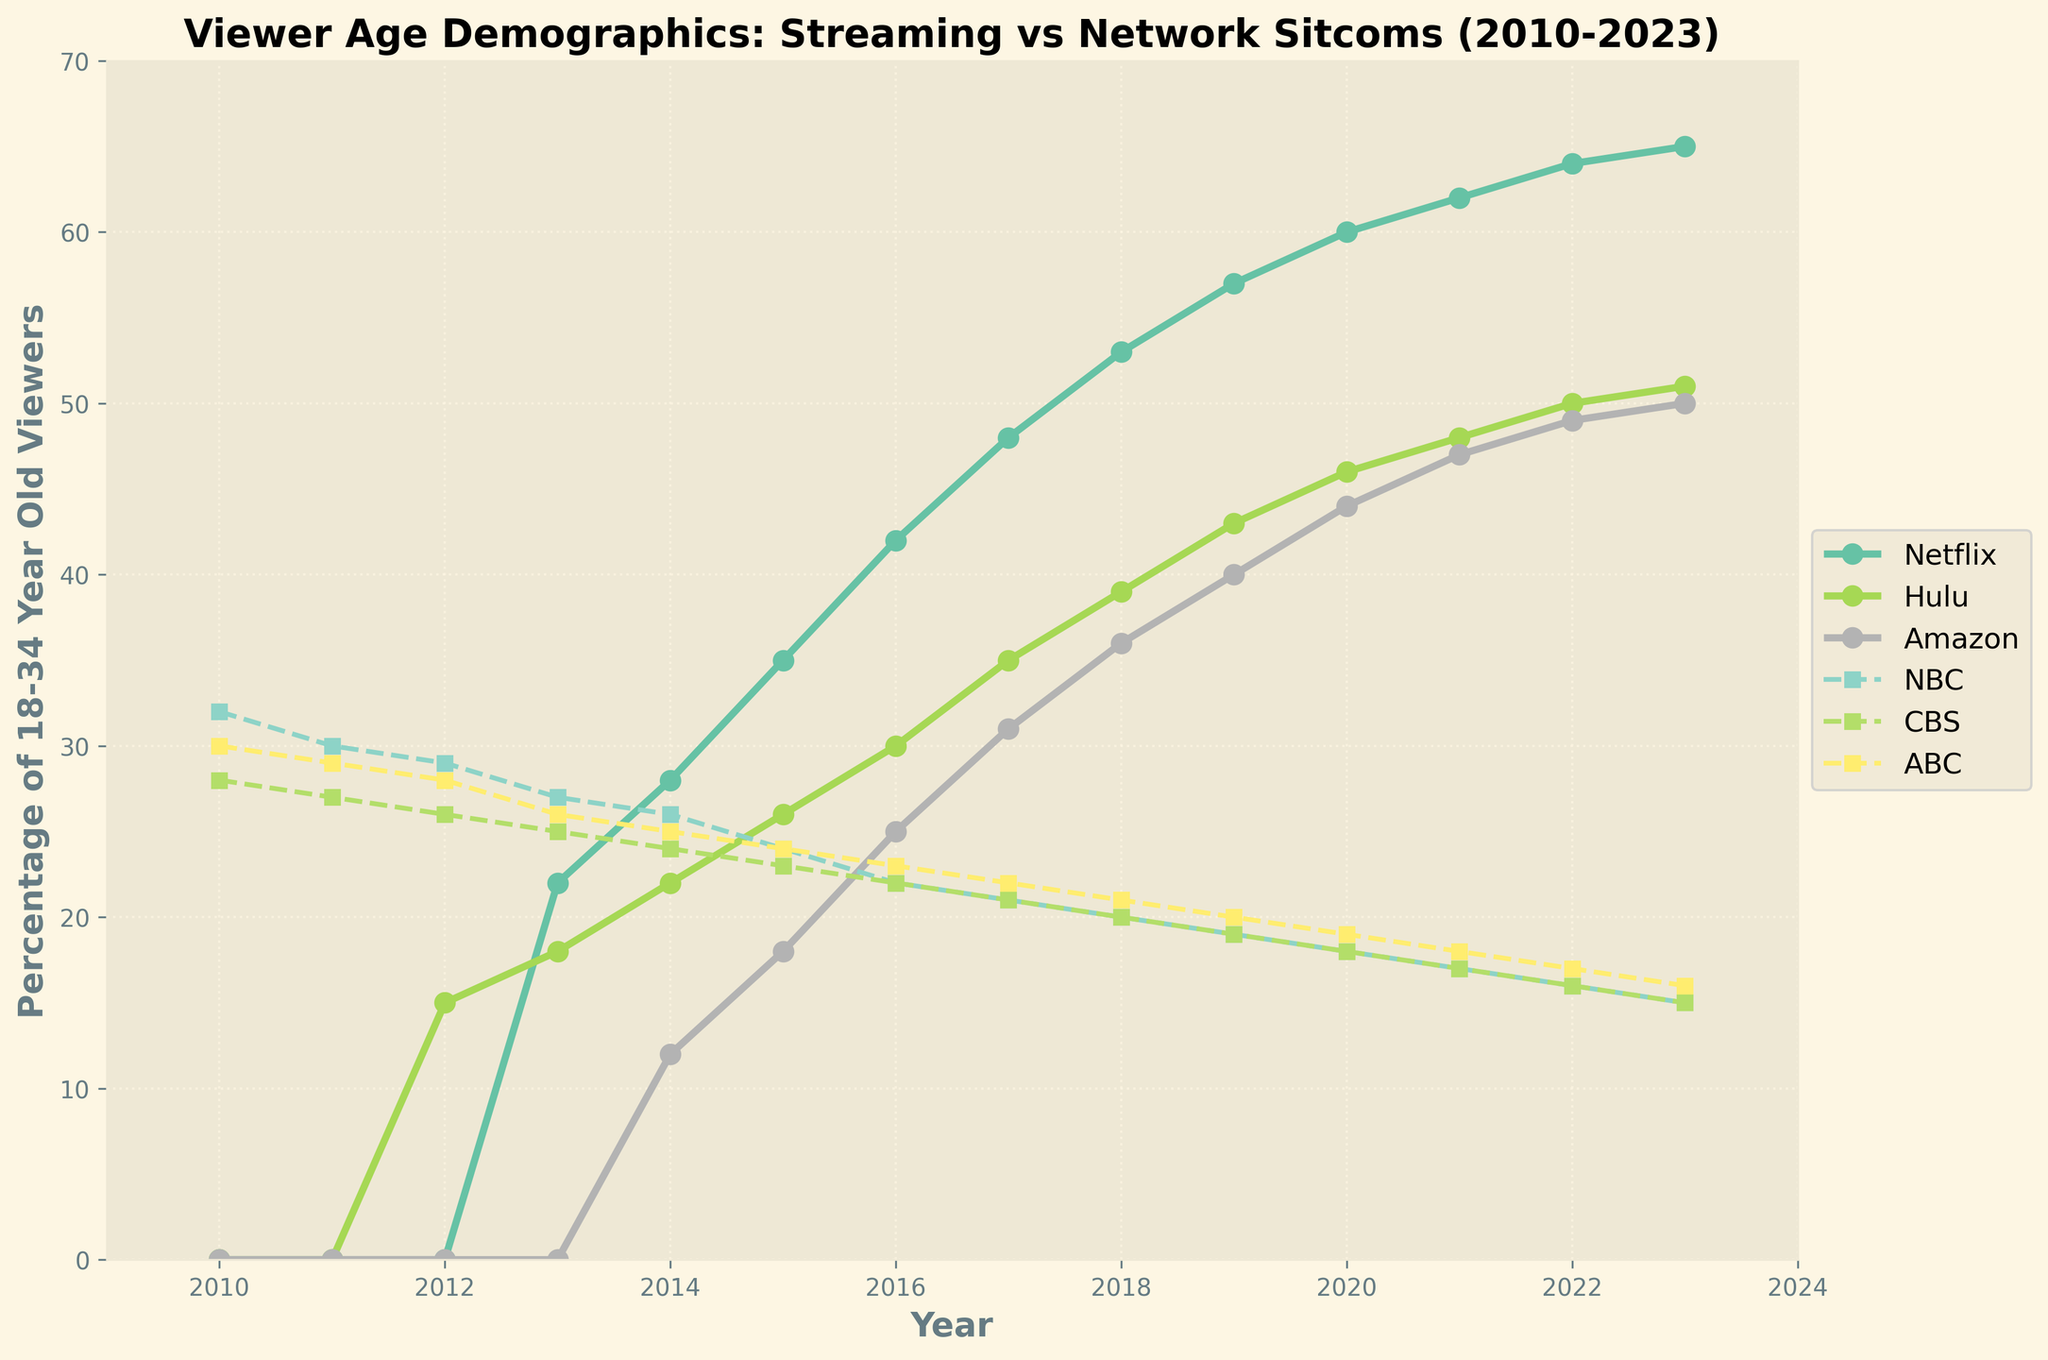What trend is observed for the percentage of 18-34-year-old viewers watching Netflix original comedies from 2010 to 2023? The trend shows a consistent increase over the years. Starting at 0% in 2010, it rises markedly until it reaches 65% in 2023.
Answer: Consistent increase Is the percentage of 18-34-year-old viewers for ABC sitcoms increasing or decreasing from 2010 to 2023? The percentage is decreasing every year. It starts at 30% in 2010 and goes down to 16% by 2023.
Answer: Decreasing In 2018, which platform or network had the highest percentage of 18-34-year-old viewers? To find this, we check the data points for 2018. Netflix had 53%, Hulu had 39%, Amazon Prime had 36%, NBC had 20%, CBS had 20%, and ABC had 21%. Netflix has the highest percentage.
Answer: Netflix What's the percentage difference between Hulu and NBC for the 18-34-year-old demographic in 2023? In 2023, Hulu stands at 51% and NBC is at 15%. The difference is 51% - 15%.
Answer: 36% How does the percentage of 18-34-year-old viewers for Amazon Prime trend from 2012 to 2023? Amazon Prime starts with 0% in 2012, increases gradually each year, reaching 50% in 2023.
Answer: Increasing Compare the average percentage of 18-34-year-old viewers for Hulu and ABC from 2010 to 2023. First, sum up the percentages from 2010 to 2023 for both Hulu and ABC. Hulu: 0 + 0 + 15 + 18 + 22 + 26 + 30 + 35 + 39 + 43 + 46 + 48 + 50 + 51 = 423. ABC: 30 + 29 + 28 + 26 + 25 + 24 + 23 + 22 + 21 + 20 + 19 + 18 + 17 + 16 = 318. Divide each sum by 14: Hulu: 423 / 14 ≈ 30.21 and ABC: 318 / 14 ≈ 22.71.
Answer: Hulu: ~30.21, ABC: ~22.71 What is the visual trend of the colors used to represent streaming platforms versus network channels? Streaming platforms are represented with solid lines and bright colors like light green and yellow, whereas network channels use dashed lines and more muted colors like brown and light blue.
Answer: Bright solid vs. muted dashed By how much did the percentage of 18-34-year-old viewers for CBS decline from 2010 to 2023? In 2010, CBS had 28% and in 2023, it had 15%. The decline is 28% - 15%.
Answer: 13% In which year did Amazon Prime see the largest increase in the percentage of 18-34-year-old viewers compared to the previous year? Amazon Prime's largest increase was from 2014 to 2015, going from 12% to 18%, which is a 6% increase.
Answer: Between 2014 and 2015 